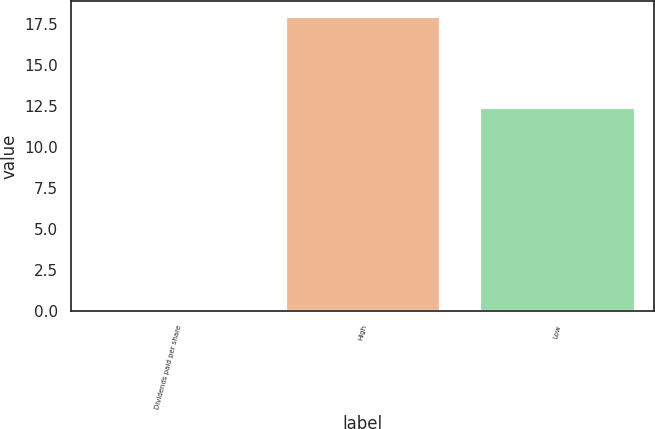Convert chart to OTSL. <chart><loc_0><loc_0><loc_500><loc_500><bar_chart><fcel>Dividends paid per share<fcel>High<fcel>Low<nl><fcel>0.15<fcel>18<fcel>12.46<nl></chart> 